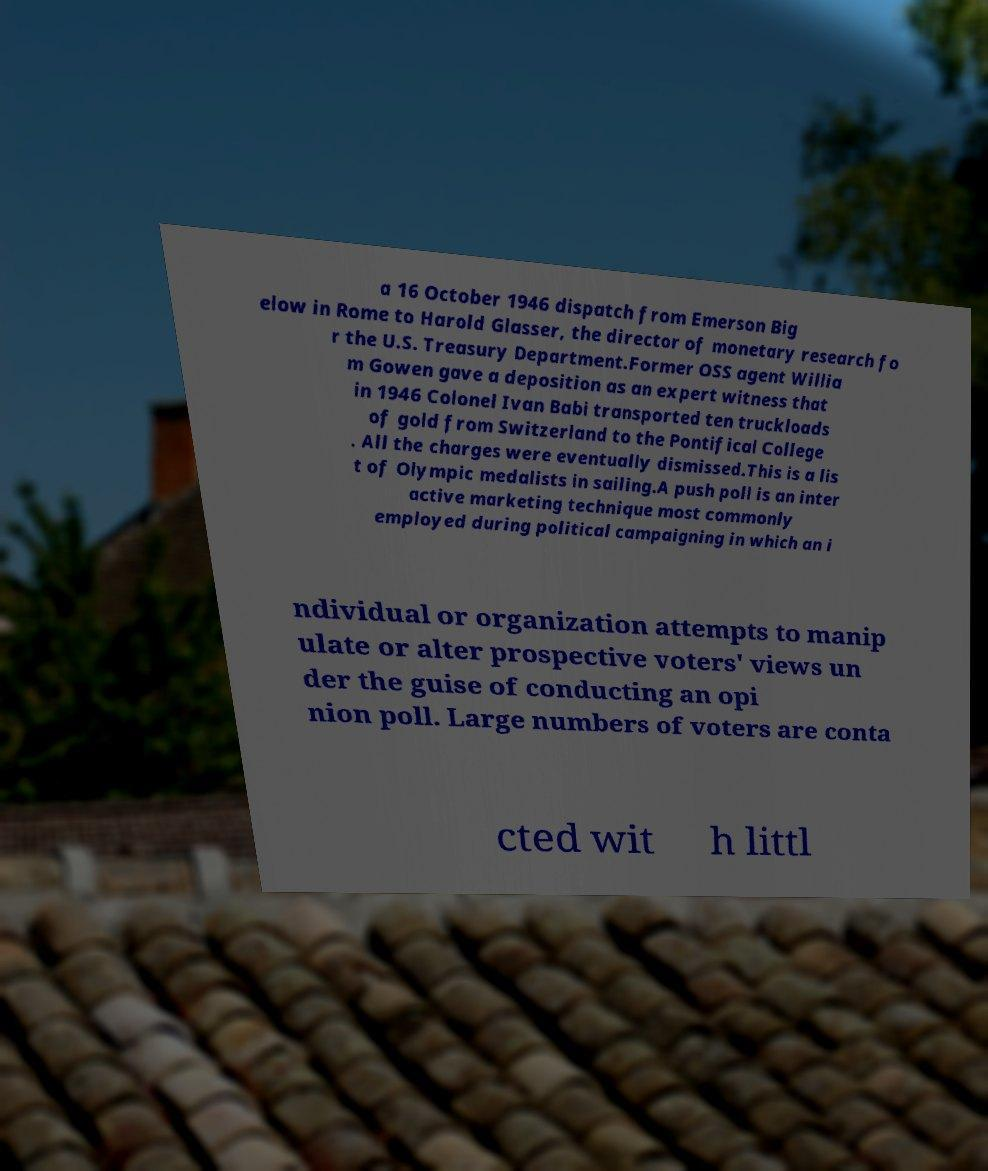Can you read and provide the text displayed in the image?This photo seems to have some interesting text. Can you extract and type it out for me? a 16 October 1946 dispatch from Emerson Big elow in Rome to Harold Glasser, the director of monetary research fo r the U.S. Treasury Department.Former OSS agent Willia m Gowen gave a deposition as an expert witness that in 1946 Colonel Ivan Babi transported ten truckloads of gold from Switzerland to the Pontifical College . All the charges were eventually dismissed.This is a lis t of Olympic medalists in sailing.A push poll is an inter active marketing technique most commonly employed during political campaigning in which an i ndividual or organization attempts to manip ulate or alter prospective voters' views un der the guise of conducting an opi nion poll. Large numbers of voters are conta cted wit h littl 